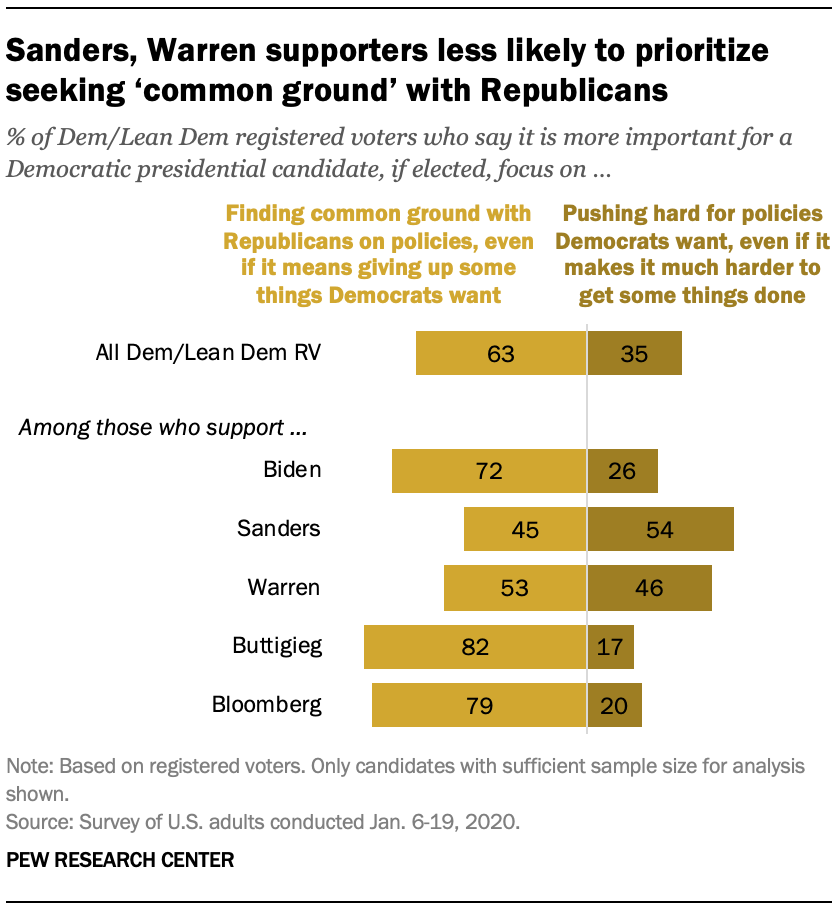Highlight a few significant elements in this photo. The sum of the medians of the lighter and darker bars is 99. 